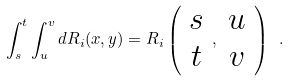Convert formula to latex. <formula><loc_0><loc_0><loc_500><loc_500>\int _ { s } ^ { t } \int _ { u } ^ { v } d R _ { i } ( x , y ) = R _ { i } \left ( \begin{array} { c } s \\ t \end{array} , \begin{array} { c } u \\ v \end{array} \right ) \ .</formula> 